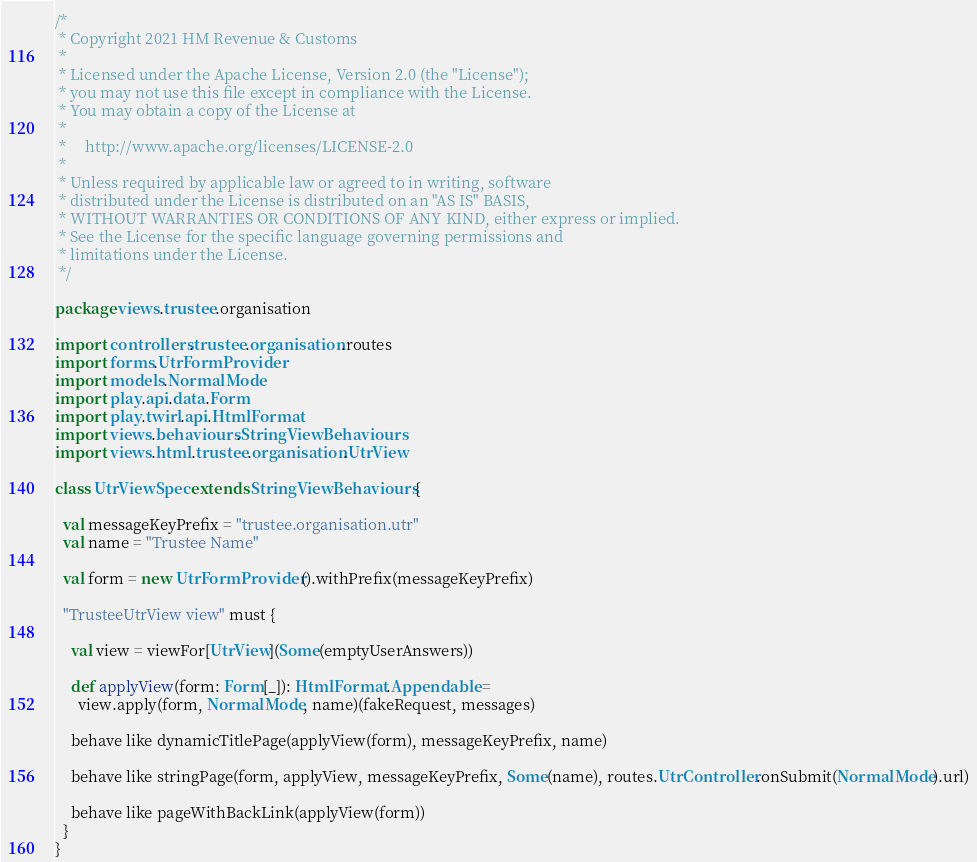<code> <loc_0><loc_0><loc_500><loc_500><_Scala_>/*
 * Copyright 2021 HM Revenue & Customs
 *
 * Licensed under the Apache License, Version 2.0 (the "License");
 * you may not use this file except in compliance with the License.
 * You may obtain a copy of the License at
 *
 *     http://www.apache.org/licenses/LICENSE-2.0
 *
 * Unless required by applicable law or agreed to in writing, software
 * distributed under the License is distributed on an "AS IS" BASIS,
 * WITHOUT WARRANTIES OR CONDITIONS OF ANY KIND, either express or implied.
 * See the License for the specific language governing permissions and
 * limitations under the License.
 */

package views.trustee.organisation

import controllers.trustee.organisation.routes
import forms.UtrFormProvider
import models.NormalMode
import play.api.data.Form
import play.twirl.api.HtmlFormat
import views.behaviours.StringViewBehaviours
import views.html.trustee.organisation.UtrView

class UtrViewSpec extends StringViewBehaviours {

  val messageKeyPrefix = "trustee.organisation.utr"
  val name = "Trustee Name"

  val form = new UtrFormProvider().withPrefix(messageKeyPrefix)

  "TrusteeUtrView view" must {

    val view = viewFor[UtrView](Some(emptyUserAnswers))

    def applyView(form: Form[_]): HtmlFormat.Appendable =
      view.apply(form, NormalMode, name)(fakeRequest, messages)

    behave like dynamicTitlePage(applyView(form), messageKeyPrefix, name)

    behave like stringPage(form, applyView, messageKeyPrefix, Some(name), routes.UtrController.onSubmit(NormalMode).url)

    behave like pageWithBackLink(applyView(form))
  }
}
</code> 